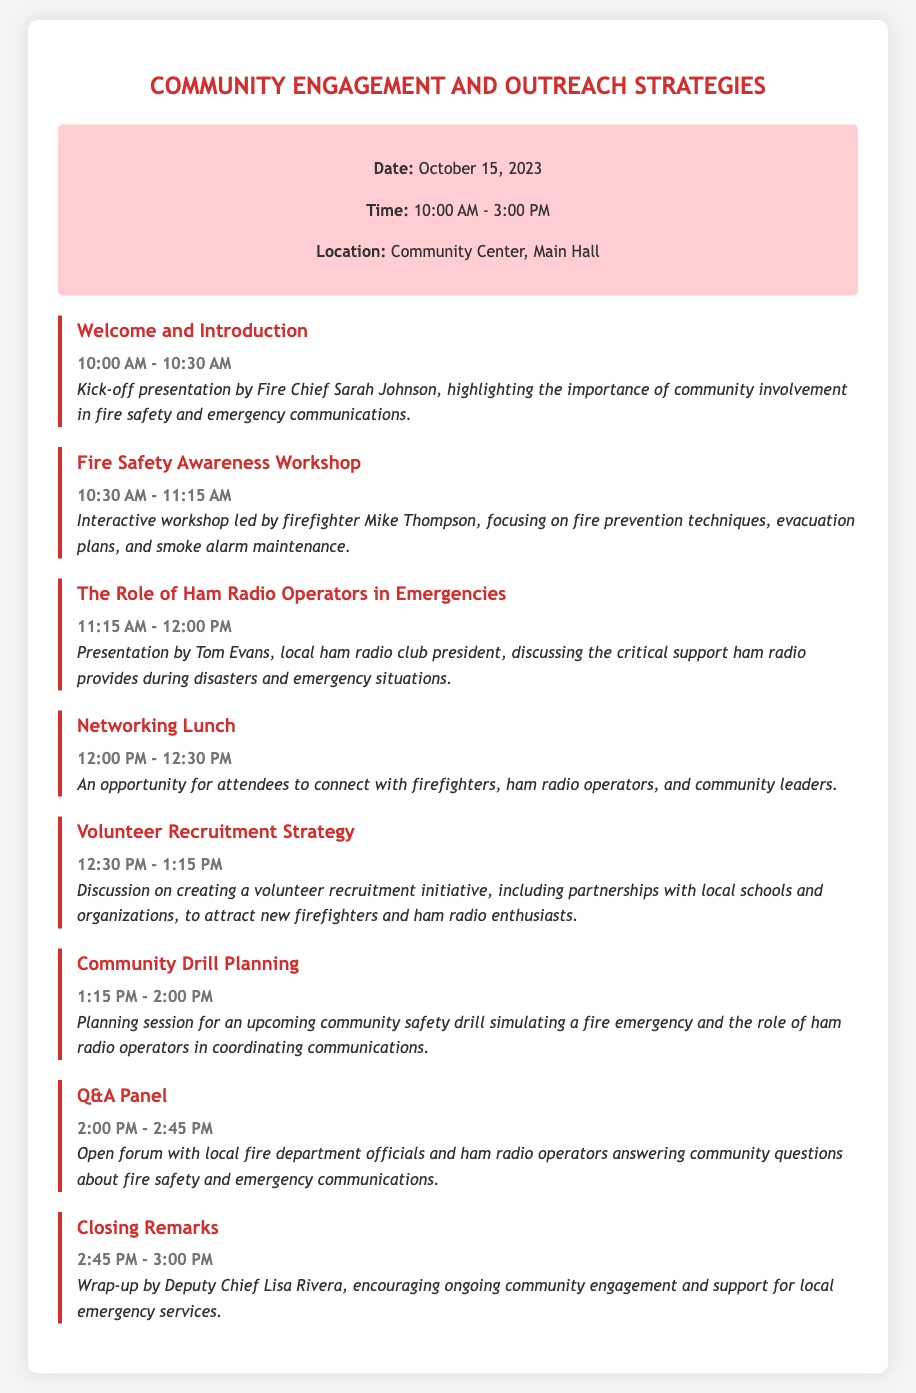what is the date of the event? The event is scheduled for October 15, 2023, as stated in the event information section.
Answer: October 15, 2023 what is the location of the event? The document specifies that the event will take place at the Community Center, Main Hall.
Answer: Community Center, Main Hall who is presenting the workshop on fire safety awareness? The workshop is led by firefighter Mike Thompson, as mentioned in the details of the agenda item.
Answer: Mike Thompson what is the purpose of the Networking Lunch? The details indicate that it is an opportunity for attendees to connect with firefighters, ham radio operators, and community leaders.
Answer: Connect with firefighters, ham radio operators, and community leaders how long is the Q&A Panel session? The time allocated for the Q&A panel is mentioned as 45 minutes from 2:00 PM to 2:45 PM.
Answer: 45 minutes who wraps up the event with closing remarks? The closing remarks are delivered by Deputy Chief Lisa Rivera, as stated in the final agenda item.
Answer: Deputy Chief Lisa Rivera what topic is covered in the session about the role of ham radio operators? The presentation covers the critical support ham radio provides during disasters and emergency situations, highlighting its importance in the context of the agenda.
Answer: Critical support during disasters and emergency situations what is one aim of the Volunteer Recruitment Strategy discussion? The discussion aims to create a volunteer recruitment initiative to attract new firefighters and ham radio enthusiasts, as indicated in the agenda details.
Answer: Attract new firefighters and ham radio enthusiasts 